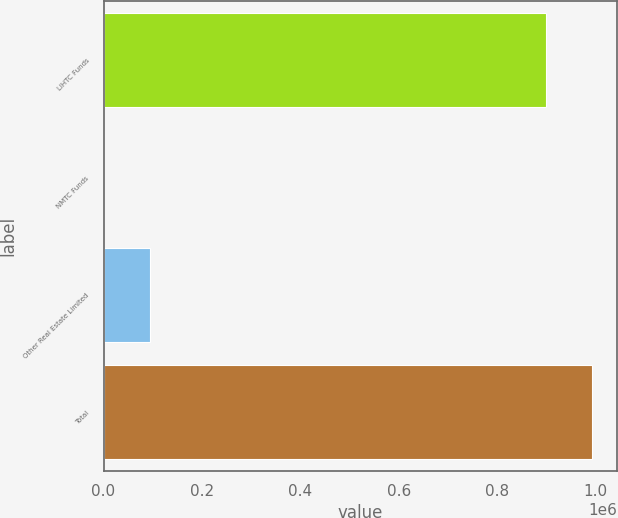Convert chart to OTSL. <chart><loc_0><loc_0><loc_500><loc_500><bar_chart><fcel>LIHTC Funds<fcel>NMTC Funds<fcel>Other Real Estate Limited<fcel>Total<nl><fcel>899586<fcel>2<fcel>93586.8<fcel>993171<nl></chart> 